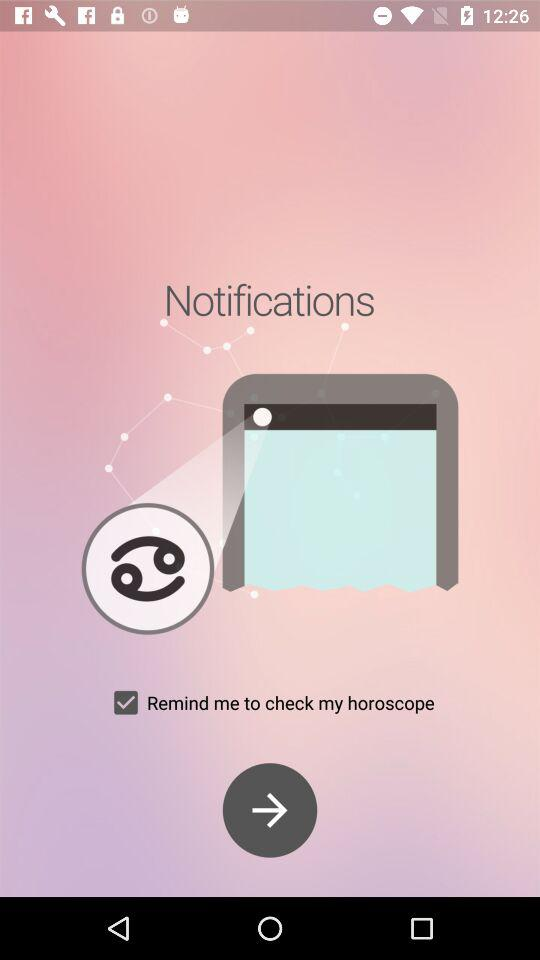What is the status of "Remind me to check my horoscope"? The status is "on". 